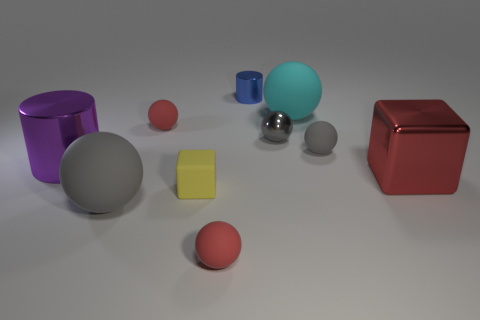Subtract all cyan cylinders. How many red spheres are left? 2 Subtract all shiny spheres. How many spheres are left? 5 Subtract 1 balls. How many balls are left? 5 Subtract all cyan balls. How many balls are left? 5 Subtract all brown spheres. Subtract all blue cylinders. How many spheres are left? 6 Subtract all spheres. How many objects are left? 4 Add 4 small spheres. How many small spheres are left? 8 Add 2 cyan metallic objects. How many cyan metallic objects exist? 2 Subtract 0 gray cylinders. How many objects are left? 10 Subtract all big cylinders. Subtract all small cylinders. How many objects are left? 8 